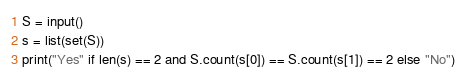<code> <loc_0><loc_0><loc_500><loc_500><_Python_>S = input()
s = list(set(S))
print("Yes" if len(s) == 2 and S.count(s[0]) == S.count(s[1]) == 2 else "No")</code> 